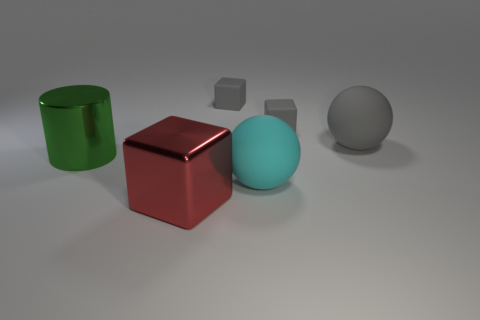Which of the objects seems out of place compared to the others? While each object has its unique color and shape, the smaller gray cube seems slightly out of place because it's the only object that's much smaller in size compared to the rest. What does that tell us about the scene? The presence of the smaller gray cube among the larger objects might suggest a study on perspectives, scale, or could be an intentional choice to provide a contrast in size, emphasizing the larger objects' dimensions and the scene's overall composition. 